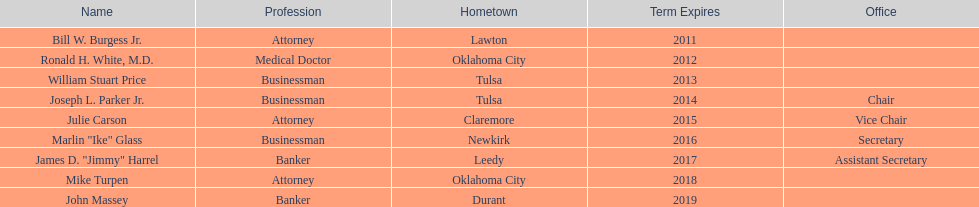How many of the present state regents possess a recorded office title? 4. 